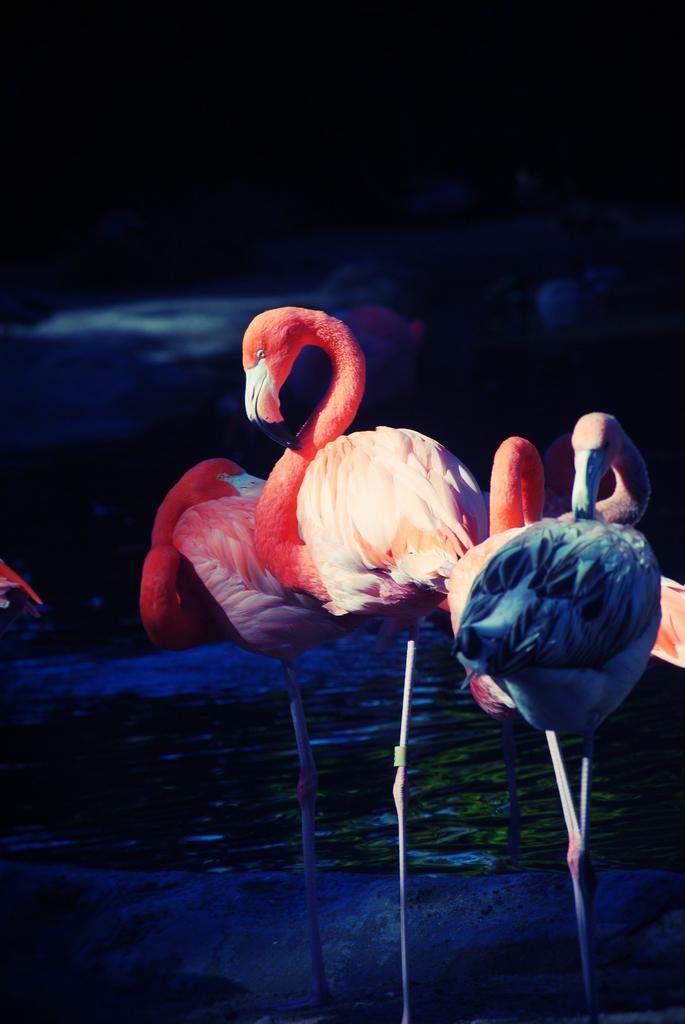In one or two sentences, can you explain what this image depicts? In this image we can see birds. In the back there is water. In the background it is dark. 